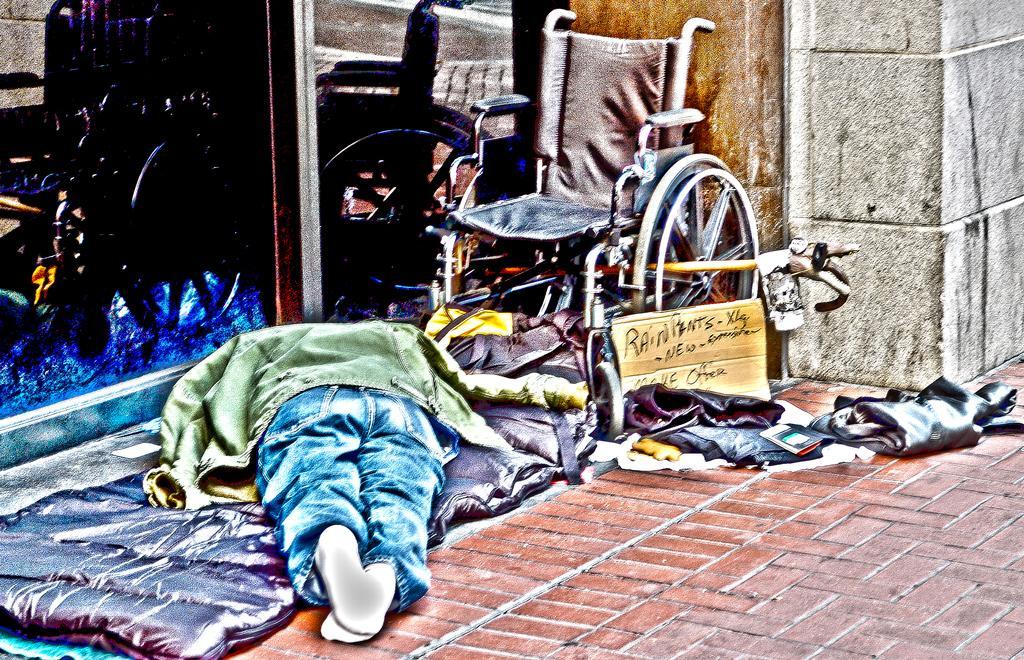Please provide a concise description of this image. In the foreground of this picture, there is a man sleeping on a bed on the floor and we can also see a wheel chair, a stick and few clothes on the side path placed beside him. In the background, there is a glass and a wall. 